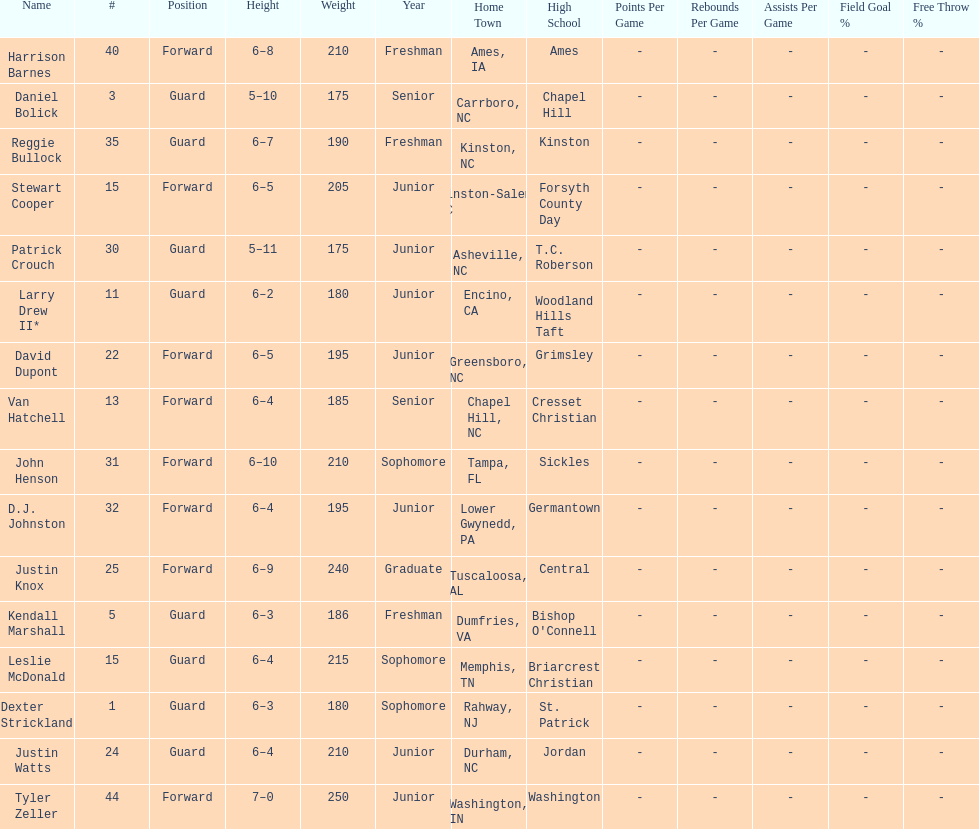How many players play a position other than guard? 8. 